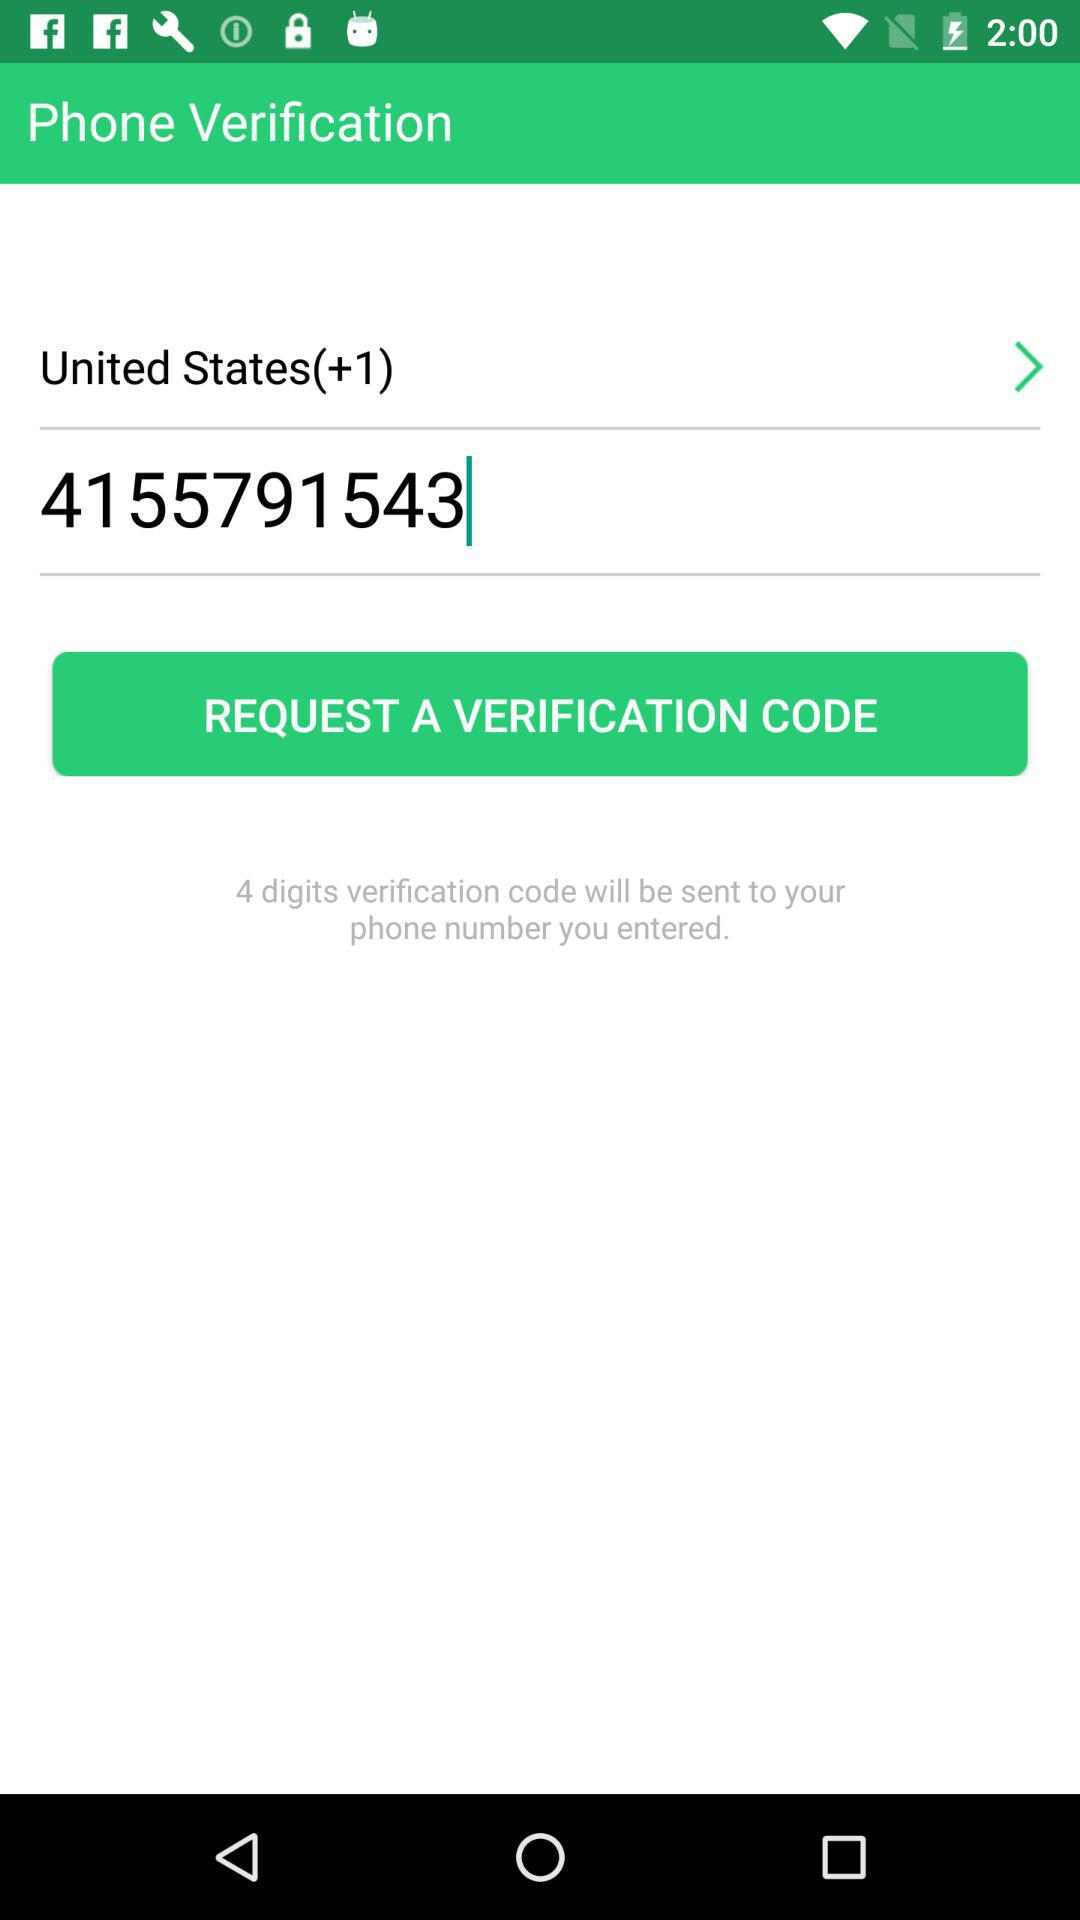What is the verification code?
When the provided information is insufficient, respond with <no answer>. <no answer> 